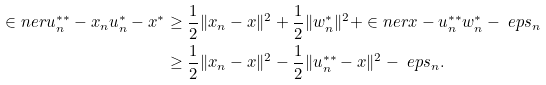Convert formula to latex. <formula><loc_0><loc_0><loc_500><loc_500>\in n e r { u _ { n } ^ { * * } - x _ { n } } { u _ { n } ^ { * } - x ^ { * } } & \geq \frac { 1 } { 2 } \| x _ { n } - x \| ^ { 2 } + \frac { 1 } { 2 } \| w _ { n } ^ { * } \| ^ { 2 } + \in n e r { x - u _ { n } ^ { * * } } { w _ { n } ^ { * } } - \ e p s _ { n } \\ & \geq \frac { 1 } { 2 } \| x _ { n } - x \| ^ { 2 } - \frac { 1 } { 2 } \| u _ { n } ^ { * * } - x \| ^ { 2 } - \ e p s _ { n } .</formula> 